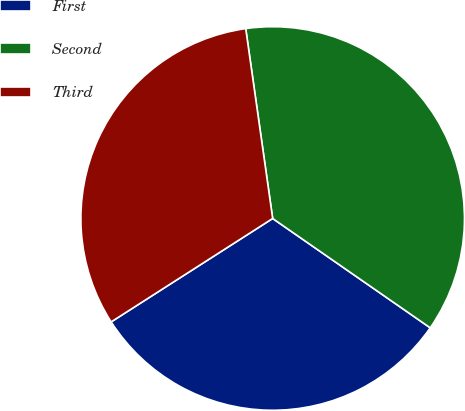<chart> <loc_0><loc_0><loc_500><loc_500><pie_chart><fcel>First<fcel>Second<fcel>Third<nl><fcel>31.28%<fcel>36.9%<fcel>31.82%<nl></chart> 